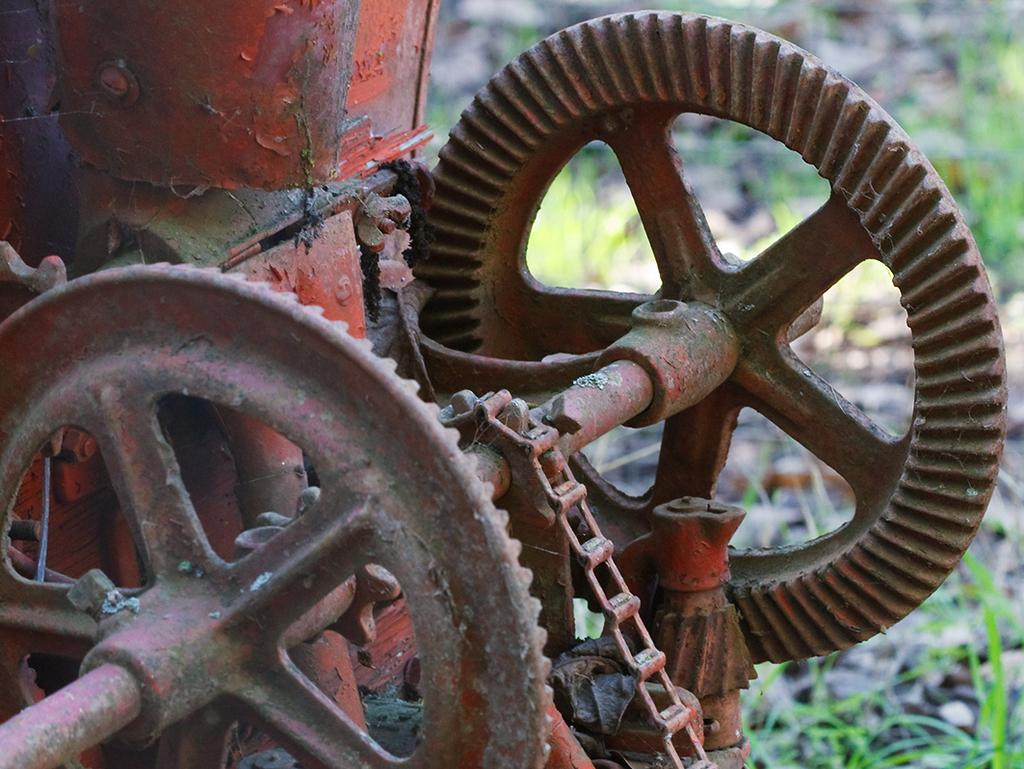What is the main subject of the image? There is an equipment in the image. Can you describe the appearance of the equipment? The equipment is brown and red in color. What can be seen in the background of the image? There is grass visible in the background of the image. What type of lock is used to secure the room in the image? There is no lock or room present in the image; it features an equipment and grass in the background. What type of plough is being used in the image? There is no plough present in the image; it features an equipment and grass in the background. 